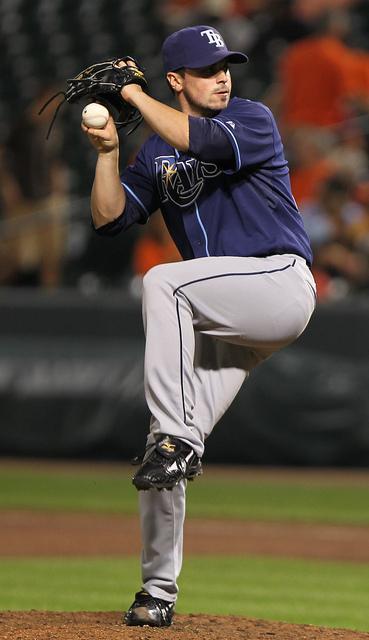How many people are there?
Give a very brief answer. 2. How many baseball gloves are there?
Give a very brief answer. 1. How many cupcakes have an elephant on them?
Give a very brief answer. 0. 